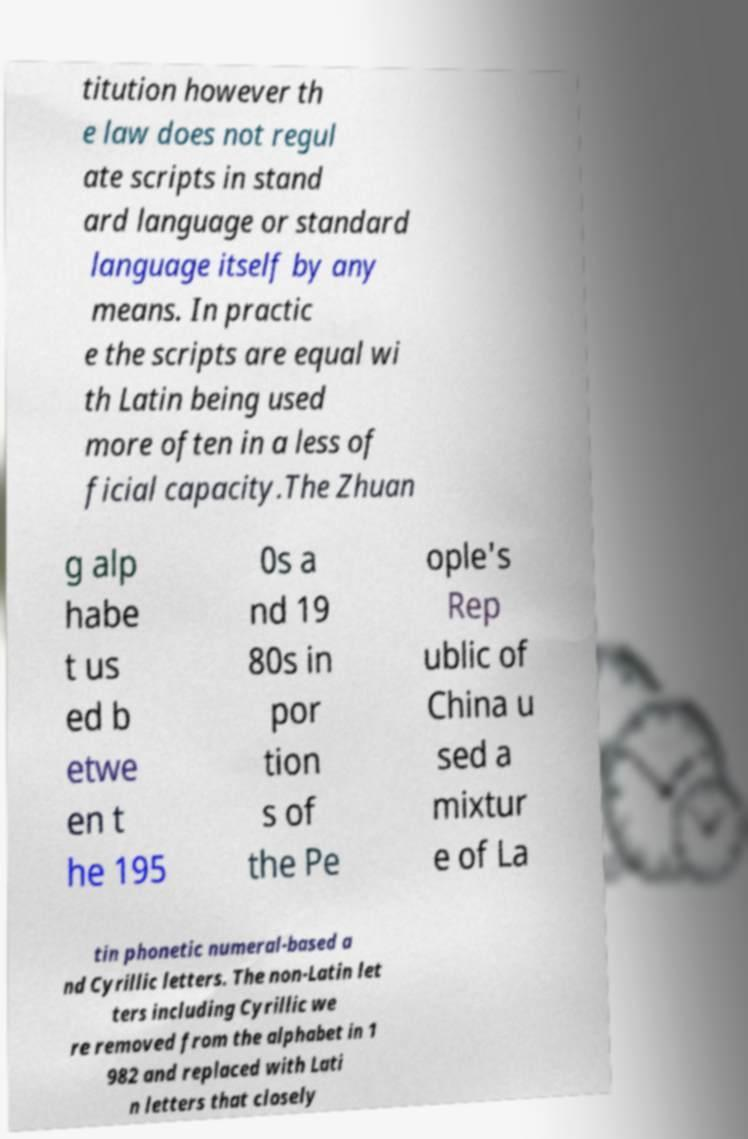There's text embedded in this image that I need extracted. Can you transcribe it verbatim? titution however th e law does not regul ate scripts in stand ard language or standard language itself by any means. In practic e the scripts are equal wi th Latin being used more often in a less of ficial capacity.The Zhuan g alp habe t us ed b etwe en t he 195 0s a nd 19 80s in por tion s of the Pe ople's Rep ublic of China u sed a mixtur e of La tin phonetic numeral-based a nd Cyrillic letters. The non-Latin let ters including Cyrillic we re removed from the alphabet in 1 982 and replaced with Lati n letters that closely 